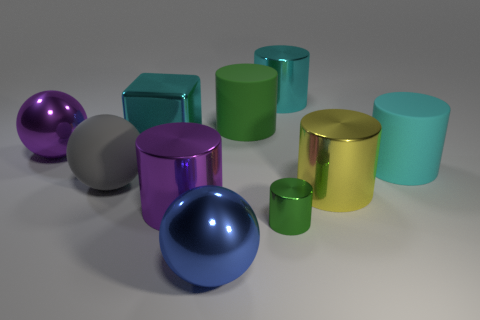How many blue things are large shiny things or big rubber objects?
Provide a short and direct response. 1. How many blue metal things have the same size as the green matte cylinder?
Offer a very short reply. 1. There is a rubber thing that is the same color as the tiny cylinder; what shape is it?
Your response must be concise. Cylinder. How many things are either metal things or large shiny things in front of the block?
Your response must be concise. 7. There is a cylinder that is to the right of the large yellow object; is its size the same as the green object in front of the yellow object?
Your answer should be compact. No. What number of other rubber objects are the same shape as the yellow object?
Offer a terse response. 2. The green object that is the same material as the large yellow cylinder is what shape?
Keep it short and to the point. Cylinder. There is a cyan cylinder that is on the right side of the cyan thing behind the green cylinder behind the big gray object; what is it made of?
Provide a succinct answer. Rubber. Do the gray object and the purple thing left of the cyan shiny block have the same size?
Your answer should be compact. Yes. There is a tiny green thing that is the same shape as the large yellow shiny thing; what is its material?
Keep it short and to the point. Metal. 